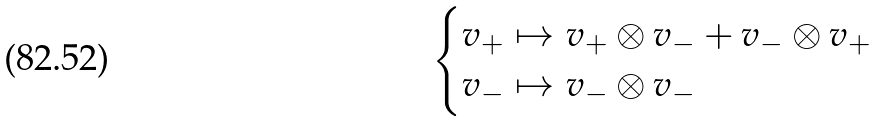<formula> <loc_0><loc_0><loc_500><loc_500>\begin{cases} v _ { + } \mapsto v _ { + } \otimes v _ { - } + v _ { - } \otimes v _ { + } & \\ v _ { - } \mapsto v _ { - } \otimes v _ { - } & \end{cases}</formula> 